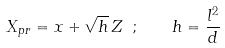<formula> <loc_0><loc_0><loc_500><loc_500>X _ { p r } = x + \sqrt { h } \, Z \ ; \, \quad h = \frac { l ^ { 2 } } { d } \,</formula> 